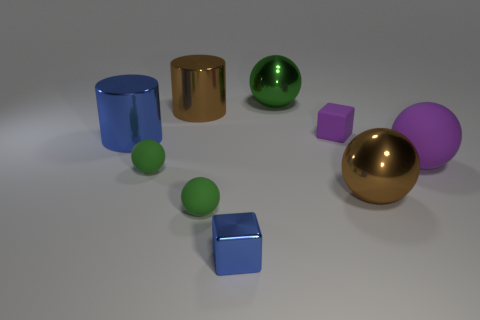What number of small purple metallic blocks are there?
Provide a succinct answer. 0. What color is the metal thing that is in front of the big brown metallic ball?
Your response must be concise. Blue. The ball in front of the large brown thing that is to the right of the tiny metal object is what color?
Your response must be concise. Green. The other cube that is the same size as the blue cube is what color?
Provide a succinct answer. Purple. What number of objects are left of the big rubber ball and behind the tiny blue object?
Your response must be concise. 7. The small matte thing that is the same color as the big rubber sphere is what shape?
Your answer should be compact. Cube. The thing that is both in front of the large brown ball and behind the tiny shiny cube is made of what material?
Make the answer very short. Rubber. Are there fewer small blue blocks that are behind the brown ball than matte objects on the right side of the blue cube?
Offer a very short reply. Yes. What is the size of the other ball that is the same material as the large brown sphere?
Make the answer very short. Large. Do the small purple object and the purple thing in front of the big blue metallic cylinder have the same material?
Offer a terse response. Yes. 